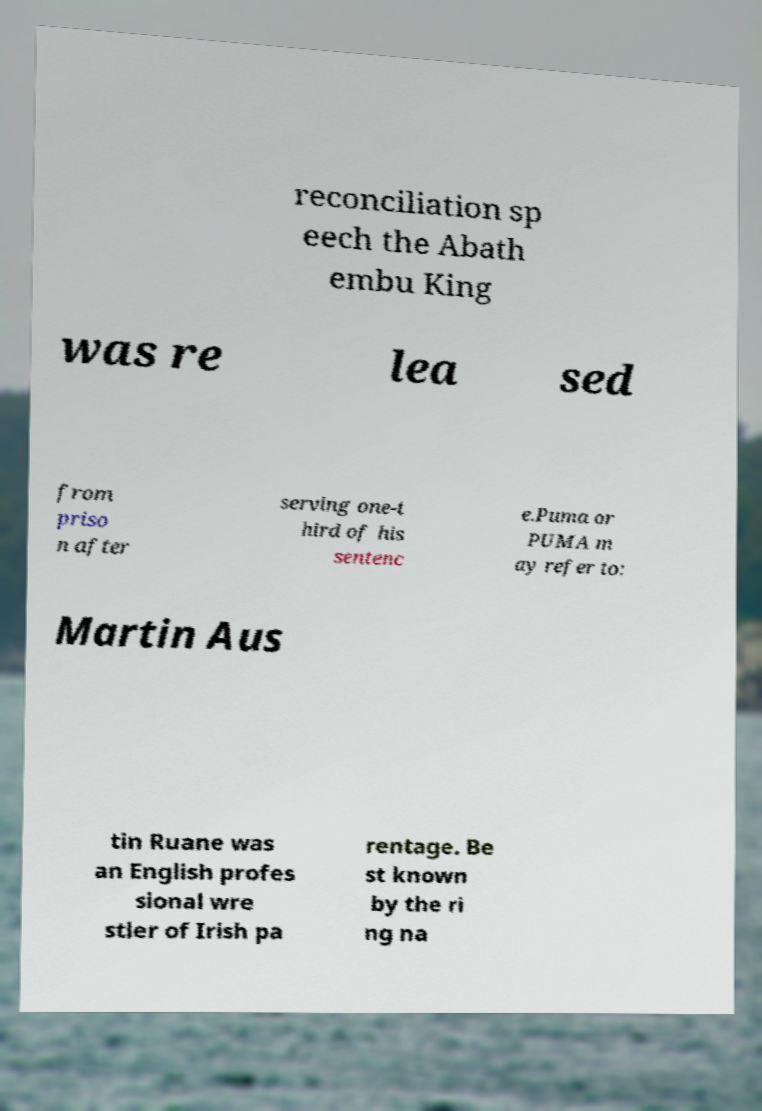Could you extract and type out the text from this image? reconciliation sp eech the Abath embu King was re lea sed from priso n after serving one-t hird of his sentenc e.Puma or PUMA m ay refer to: Martin Aus tin Ruane was an English profes sional wre stler of Irish pa rentage. Be st known by the ri ng na 